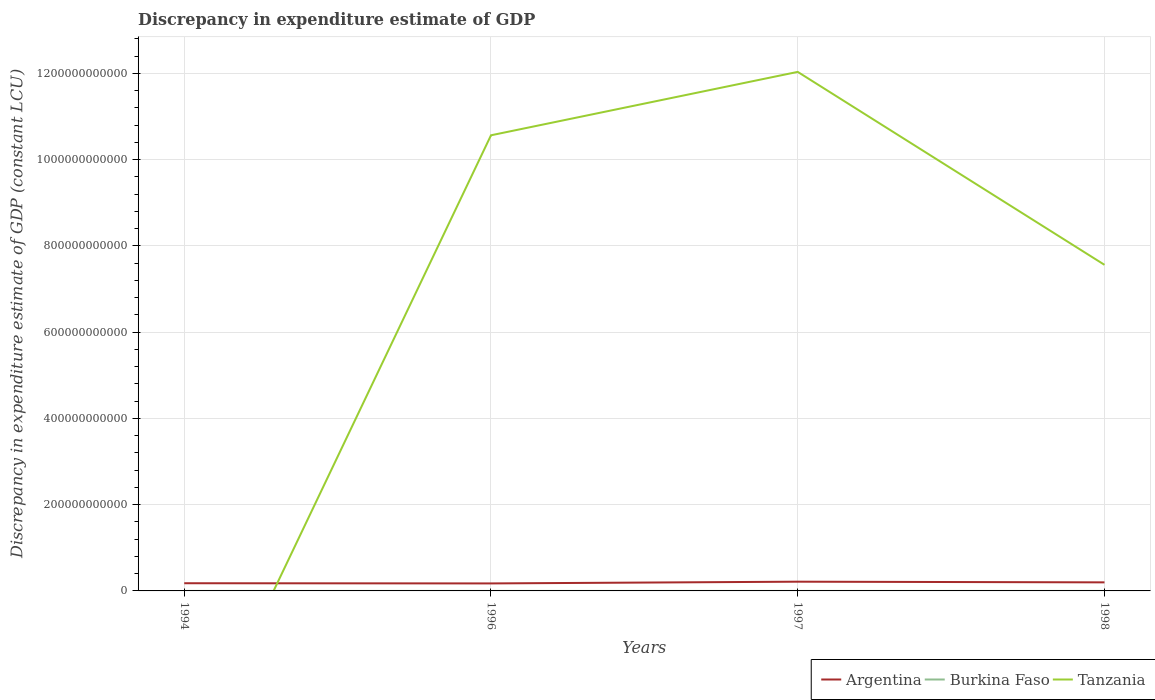Does the line corresponding to Argentina intersect with the line corresponding to Tanzania?
Your answer should be very brief. Yes. Is the number of lines equal to the number of legend labels?
Your answer should be very brief. No. Across all years, what is the maximum discrepancy in expenditure estimate of GDP in Burkina Faso?
Give a very brief answer. 0. What is the total discrepancy in expenditure estimate of GDP in Argentina in the graph?
Keep it short and to the point. -2.46e+09. What is the difference between the highest and the second highest discrepancy in expenditure estimate of GDP in Tanzania?
Your answer should be compact. 1.20e+12. What is the difference between the highest and the lowest discrepancy in expenditure estimate of GDP in Argentina?
Keep it short and to the point. 2. What is the difference between two consecutive major ticks on the Y-axis?
Your response must be concise. 2.00e+11. Does the graph contain any zero values?
Ensure brevity in your answer.  Yes. Does the graph contain grids?
Make the answer very short. Yes. How many legend labels are there?
Make the answer very short. 3. How are the legend labels stacked?
Your answer should be very brief. Horizontal. What is the title of the graph?
Your answer should be compact. Discrepancy in expenditure estimate of GDP. What is the label or title of the X-axis?
Keep it short and to the point. Years. What is the label or title of the Y-axis?
Make the answer very short. Discrepancy in expenditure estimate of GDP (constant LCU). What is the Discrepancy in expenditure estimate of GDP (constant LCU) of Argentina in 1994?
Offer a terse response. 1.78e+1. What is the Discrepancy in expenditure estimate of GDP (constant LCU) in Burkina Faso in 1994?
Make the answer very short. 3.28e+04. What is the Discrepancy in expenditure estimate of GDP (constant LCU) in Argentina in 1996?
Offer a terse response. 1.74e+1. What is the Discrepancy in expenditure estimate of GDP (constant LCU) in Burkina Faso in 1996?
Your answer should be compact. 0. What is the Discrepancy in expenditure estimate of GDP (constant LCU) in Tanzania in 1996?
Provide a short and direct response. 1.06e+12. What is the Discrepancy in expenditure estimate of GDP (constant LCU) in Argentina in 1997?
Provide a short and direct response. 2.14e+1. What is the Discrepancy in expenditure estimate of GDP (constant LCU) of Burkina Faso in 1997?
Your response must be concise. 0. What is the Discrepancy in expenditure estimate of GDP (constant LCU) in Tanzania in 1997?
Your answer should be very brief. 1.20e+12. What is the Discrepancy in expenditure estimate of GDP (constant LCU) of Argentina in 1998?
Ensure brevity in your answer.  1.98e+1. What is the Discrepancy in expenditure estimate of GDP (constant LCU) in Burkina Faso in 1998?
Ensure brevity in your answer.  1.64e+05. What is the Discrepancy in expenditure estimate of GDP (constant LCU) of Tanzania in 1998?
Provide a short and direct response. 7.56e+11. Across all years, what is the maximum Discrepancy in expenditure estimate of GDP (constant LCU) of Argentina?
Your answer should be very brief. 2.14e+1. Across all years, what is the maximum Discrepancy in expenditure estimate of GDP (constant LCU) of Burkina Faso?
Give a very brief answer. 1.64e+05. Across all years, what is the maximum Discrepancy in expenditure estimate of GDP (constant LCU) in Tanzania?
Ensure brevity in your answer.  1.20e+12. Across all years, what is the minimum Discrepancy in expenditure estimate of GDP (constant LCU) of Argentina?
Make the answer very short. 1.74e+1. Across all years, what is the minimum Discrepancy in expenditure estimate of GDP (constant LCU) in Burkina Faso?
Your response must be concise. 0. Across all years, what is the minimum Discrepancy in expenditure estimate of GDP (constant LCU) of Tanzania?
Offer a terse response. 0. What is the total Discrepancy in expenditure estimate of GDP (constant LCU) of Argentina in the graph?
Provide a succinct answer. 7.65e+1. What is the total Discrepancy in expenditure estimate of GDP (constant LCU) of Burkina Faso in the graph?
Give a very brief answer. 1.97e+05. What is the total Discrepancy in expenditure estimate of GDP (constant LCU) in Tanzania in the graph?
Keep it short and to the point. 3.02e+12. What is the difference between the Discrepancy in expenditure estimate of GDP (constant LCU) in Argentina in 1994 and that in 1996?
Make the answer very short. 4.63e+08. What is the difference between the Discrepancy in expenditure estimate of GDP (constant LCU) of Argentina in 1994 and that in 1997?
Provide a succinct answer. -3.57e+09. What is the difference between the Discrepancy in expenditure estimate of GDP (constant LCU) in Argentina in 1994 and that in 1998?
Make the answer very short. -2.00e+09. What is the difference between the Discrepancy in expenditure estimate of GDP (constant LCU) in Burkina Faso in 1994 and that in 1998?
Provide a succinct answer. -1.31e+05. What is the difference between the Discrepancy in expenditure estimate of GDP (constant LCU) in Argentina in 1996 and that in 1997?
Offer a terse response. -4.03e+09. What is the difference between the Discrepancy in expenditure estimate of GDP (constant LCU) in Tanzania in 1996 and that in 1997?
Your answer should be very brief. -1.47e+11. What is the difference between the Discrepancy in expenditure estimate of GDP (constant LCU) in Argentina in 1996 and that in 1998?
Provide a succinct answer. -2.46e+09. What is the difference between the Discrepancy in expenditure estimate of GDP (constant LCU) of Tanzania in 1996 and that in 1998?
Offer a terse response. 3.00e+11. What is the difference between the Discrepancy in expenditure estimate of GDP (constant LCU) of Argentina in 1997 and that in 1998?
Offer a terse response. 1.57e+09. What is the difference between the Discrepancy in expenditure estimate of GDP (constant LCU) in Tanzania in 1997 and that in 1998?
Provide a succinct answer. 4.47e+11. What is the difference between the Discrepancy in expenditure estimate of GDP (constant LCU) in Argentina in 1994 and the Discrepancy in expenditure estimate of GDP (constant LCU) in Tanzania in 1996?
Your response must be concise. -1.04e+12. What is the difference between the Discrepancy in expenditure estimate of GDP (constant LCU) in Burkina Faso in 1994 and the Discrepancy in expenditure estimate of GDP (constant LCU) in Tanzania in 1996?
Provide a short and direct response. -1.06e+12. What is the difference between the Discrepancy in expenditure estimate of GDP (constant LCU) of Argentina in 1994 and the Discrepancy in expenditure estimate of GDP (constant LCU) of Tanzania in 1997?
Give a very brief answer. -1.19e+12. What is the difference between the Discrepancy in expenditure estimate of GDP (constant LCU) in Burkina Faso in 1994 and the Discrepancy in expenditure estimate of GDP (constant LCU) in Tanzania in 1997?
Provide a succinct answer. -1.20e+12. What is the difference between the Discrepancy in expenditure estimate of GDP (constant LCU) in Argentina in 1994 and the Discrepancy in expenditure estimate of GDP (constant LCU) in Burkina Faso in 1998?
Your answer should be very brief. 1.78e+1. What is the difference between the Discrepancy in expenditure estimate of GDP (constant LCU) of Argentina in 1994 and the Discrepancy in expenditure estimate of GDP (constant LCU) of Tanzania in 1998?
Offer a terse response. -7.38e+11. What is the difference between the Discrepancy in expenditure estimate of GDP (constant LCU) of Burkina Faso in 1994 and the Discrepancy in expenditure estimate of GDP (constant LCU) of Tanzania in 1998?
Give a very brief answer. -7.56e+11. What is the difference between the Discrepancy in expenditure estimate of GDP (constant LCU) of Argentina in 1996 and the Discrepancy in expenditure estimate of GDP (constant LCU) of Tanzania in 1997?
Offer a very short reply. -1.19e+12. What is the difference between the Discrepancy in expenditure estimate of GDP (constant LCU) in Argentina in 1996 and the Discrepancy in expenditure estimate of GDP (constant LCU) in Burkina Faso in 1998?
Offer a terse response. 1.74e+1. What is the difference between the Discrepancy in expenditure estimate of GDP (constant LCU) in Argentina in 1996 and the Discrepancy in expenditure estimate of GDP (constant LCU) in Tanzania in 1998?
Your response must be concise. -7.39e+11. What is the difference between the Discrepancy in expenditure estimate of GDP (constant LCU) of Argentina in 1997 and the Discrepancy in expenditure estimate of GDP (constant LCU) of Burkina Faso in 1998?
Your answer should be compact. 2.14e+1. What is the difference between the Discrepancy in expenditure estimate of GDP (constant LCU) in Argentina in 1997 and the Discrepancy in expenditure estimate of GDP (constant LCU) in Tanzania in 1998?
Your answer should be compact. -7.35e+11. What is the average Discrepancy in expenditure estimate of GDP (constant LCU) in Argentina per year?
Provide a succinct answer. 1.91e+1. What is the average Discrepancy in expenditure estimate of GDP (constant LCU) in Burkina Faso per year?
Offer a terse response. 4.92e+04. What is the average Discrepancy in expenditure estimate of GDP (constant LCU) of Tanzania per year?
Provide a succinct answer. 7.54e+11. In the year 1994, what is the difference between the Discrepancy in expenditure estimate of GDP (constant LCU) of Argentina and Discrepancy in expenditure estimate of GDP (constant LCU) of Burkina Faso?
Your answer should be compact. 1.78e+1. In the year 1996, what is the difference between the Discrepancy in expenditure estimate of GDP (constant LCU) of Argentina and Discrepancy in expenditure estimate of GDP (constant LCU) of Tanzania?
Give a very brief answer. -1.04e+12. In the year 1997, what is the difference between the Discrepancy in expenditure estimate of GDP (constant LCU) in Argentina and Discrepancy in expenditure estimate of GDP (constant LCU) in Tanzania?
Keep it short and to the point. -1.18e+12. In the year 1998, what is the difference between the Discrepancy in expenditure estimate of GDP (constant LCU) of Argentina and Discrepancy in expenditure estimate of GDP (constant LCU) of Burkina Faso?
Your response must be concise. 1.98e+1. In the year 1998, what is the difference between the Discrepancy in expenditure estimate of GDP (constant LCU) of Argentina and Discrepancy in expenditure estimate of GDP (constant LCU) of Tanzania?
Ensure brevity in your answer.  -7.36e+11. In the year 1998, what is the difference between the Discrepancy in expenditure estimate of GDP (constant LCU) of Burkina Faso and Discrepancy in expenditure estimate of GDP (constant LCU) of Tanzania?
Ensure brevity in your answer.  -7.56e+11. What is the ratio of the Discrepancy in expenditure estimate of GDP (constant LCU) in Argentina in 1994 to that in 1996?
Ensure brevity in your answer.  1.03. What is the ratio of the Discrepancy in expenditure estimate of GDP (constant LCU) in Argentina in 1994 to that in 1997?
Your answer should be very brief. 0.83. What is the ratio of the Discrepancy in expenditure estimate of GDP (constant LCU) in Argentina in 1994 to that in 1998?
Provide a short and direct response. 0.9. What is the ratio of the Discrepancy in expenditure estimate of GDP (constant LCU) in Burkina Faso in 1994 to that in 1998?
Provide a succinct answer. 0.2. What is the ratio of the Discrepancy in expenditure estimate of GDP (constant LCU) in Argentina in 1996 to that in 1997?
Ensure brevity in your answer.  0.81. What is the ratio of the Discrepancy in expenditure estimate of GDP (constant LCU) in Tanzania in 1996 to that in 1997?
Provide a succinct answer. 0.88. What is the ratio of the Discrepancy in expenditure estimate of GDP (constant LCU) in Argentina in 1996 to that in 1998?
Your response must be concise. 0.88. What is the ratio of the Discrepancy in expenditure estimate of GDP (constant LCU) in Tanzania in 1996 to that in 1998?
Give a very brief answer. 1.4. What is the ratio of the Discrepancy in expenditure estimate of GDP (constant LCU) of Argentina in 1997 to that in 1998?
Offer a very short reply. 1.08. What is the ratio of the Discrepancy in expenditure estimate of GDP (constant LCU) in Tanzania in 1997 to that in 1998?
Your answer should be compact. 1.59. What is the difference between the highest and the second highest Discrepancy in expenditure estimate of GDP (constant LCU) of Argentina?
Provide a short and direct response. 1.57e+09. What is the difference between the highest and the second highest Discrepancy in expenditure estimate of GDP (constant LCU) of Tanzania?
Make the answer very short. 1.47e+11. What is the difference between the highest and the lowest Discrepancy in expenditure estimate of GDP (constant LCU) of Argentina?
Give a very brief answer. 4.03e+09. What is the difference between the highest and the lowest Discrepancy in expenditure estimate of GDP (constant LCU) in Burkina Faso?
Offer a very short reply. 1.64e+05. What is the difference between the highest and the lowest Discrepancy in expenditure estimate of GDP (constant LCU) in Tanzania?
Provide a succinct answer. 1.20e+12. 